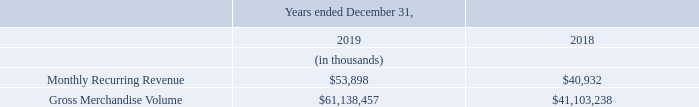Key Performance Indicators
Key performance indicators, which we do not consider to be non-GAAP measures, that we use to evaluate our business, measure our performance, identify trends affecting our business, formulate financial projections and make strategic decisions include Monthly Recurring Revenue ("MRR") and Gross Merchandise Volume ("GMV"). Our key performance indicators may be calculated in a manner different than similar key performance indicators used by other companies.
The following table shows MRR and GMV for the years ended December 31, 2019 and 2018.
What are the 2 financial items listed in the table? Monthly recurring revenue, gross merchandise volume. Which financial years' information is shown in the table? 2018, 2019. What is the full form of "MRR"? Monthly recurring revenue. What is the average monthly recurring revenue for 2018 and 2019?
Answer scale should be: thousand. (53,898+40,932)/2
Answer: 47415. What is the average gross merchandise volume for 2018 and 2019?
Answer scale should be: thousand. (61,138,457+41,103,238)/2
Answer: 51120847.5. What is the change between 2018 and 2019 year ended's monthly recurring revenue ?
Answer scale should be: thousand. 53,898-40,932
Answer: 12966. 